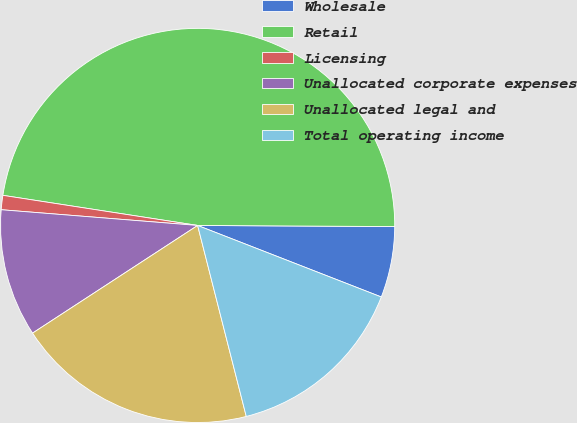<chart> <loc_0><loc_0><loc_500><loc_500><pie_chart><fcel>Wholesale<fcel>Retail<fcel>Licensing<fcel>Unallocated corporate expenses<fcel>Unallocated legal and<fcel>Total operating income<nl><fcel>5.82%<fcel>47.65%<fcel>1.17%<fcel>10.47%<fcel>19.77%<fcel>15.12%<nl></chart> 